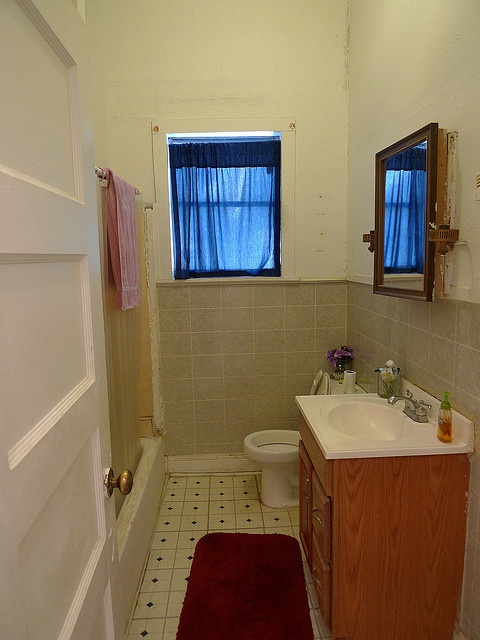Describe the objects in this image and their specific colors. I can see sink in gray and tan tones, toilet in gray and olive tones, and bottle in gray, olive, and maroon tones in this image. 